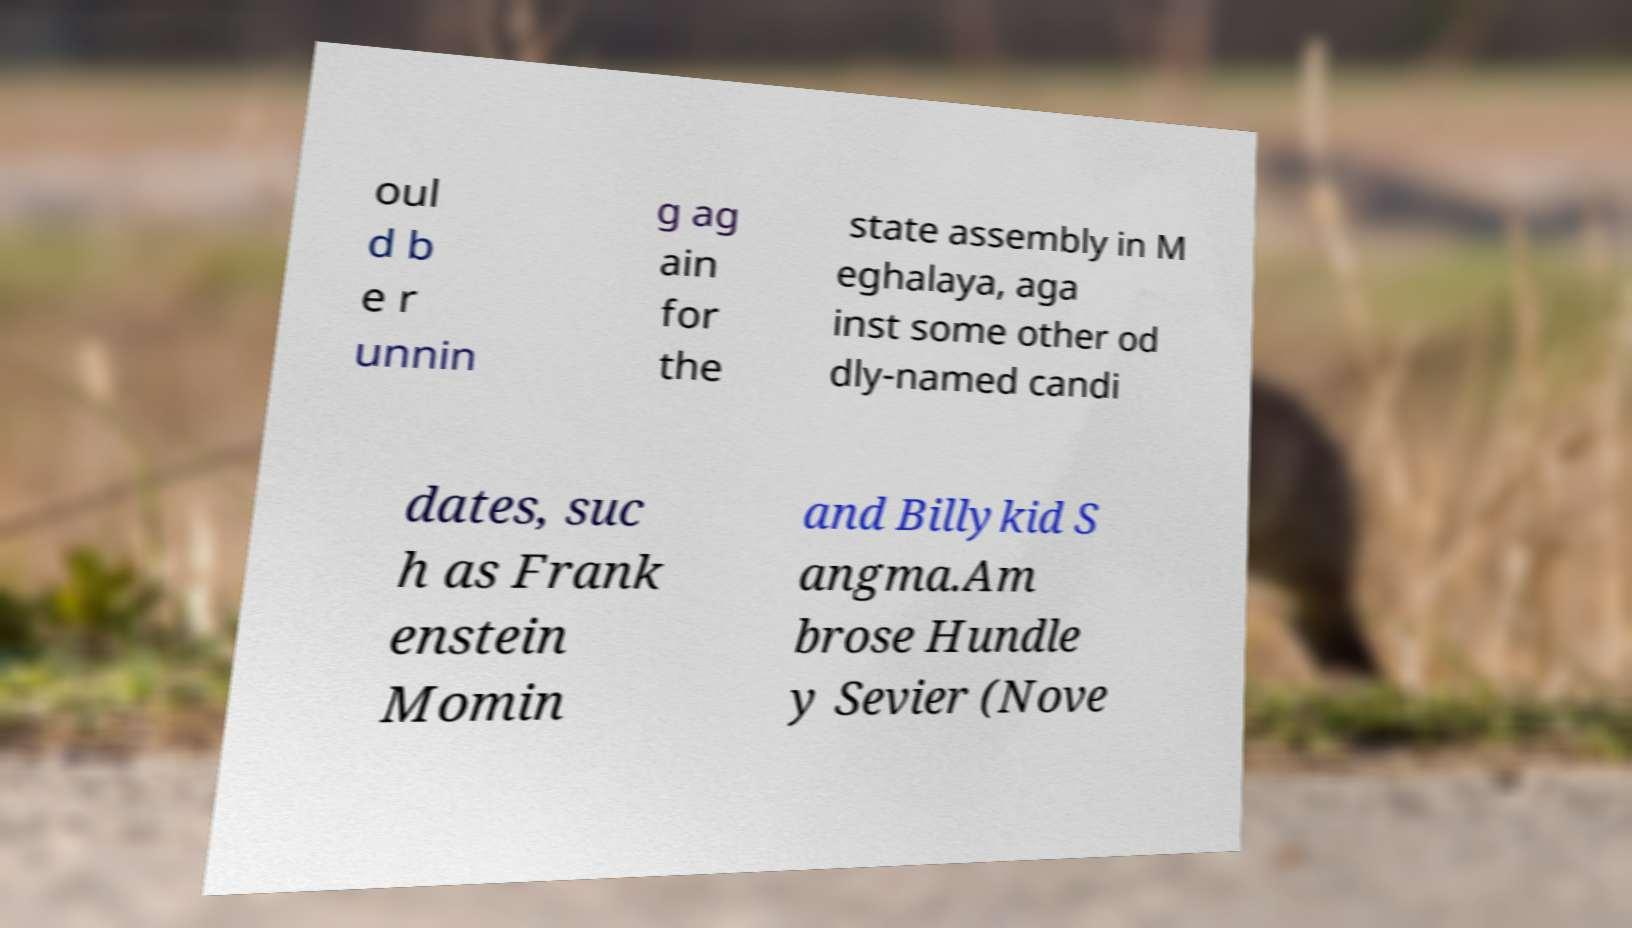Please identify and transcribe the text found in this image. oul d b e r unnin g ag ain for the state assembly in M eghalaya, aga inst some other od dly-named candi dates, suc h as Frank enstein Momin and Billykid S angma.Am brose Hundle y Sevier (Nove 